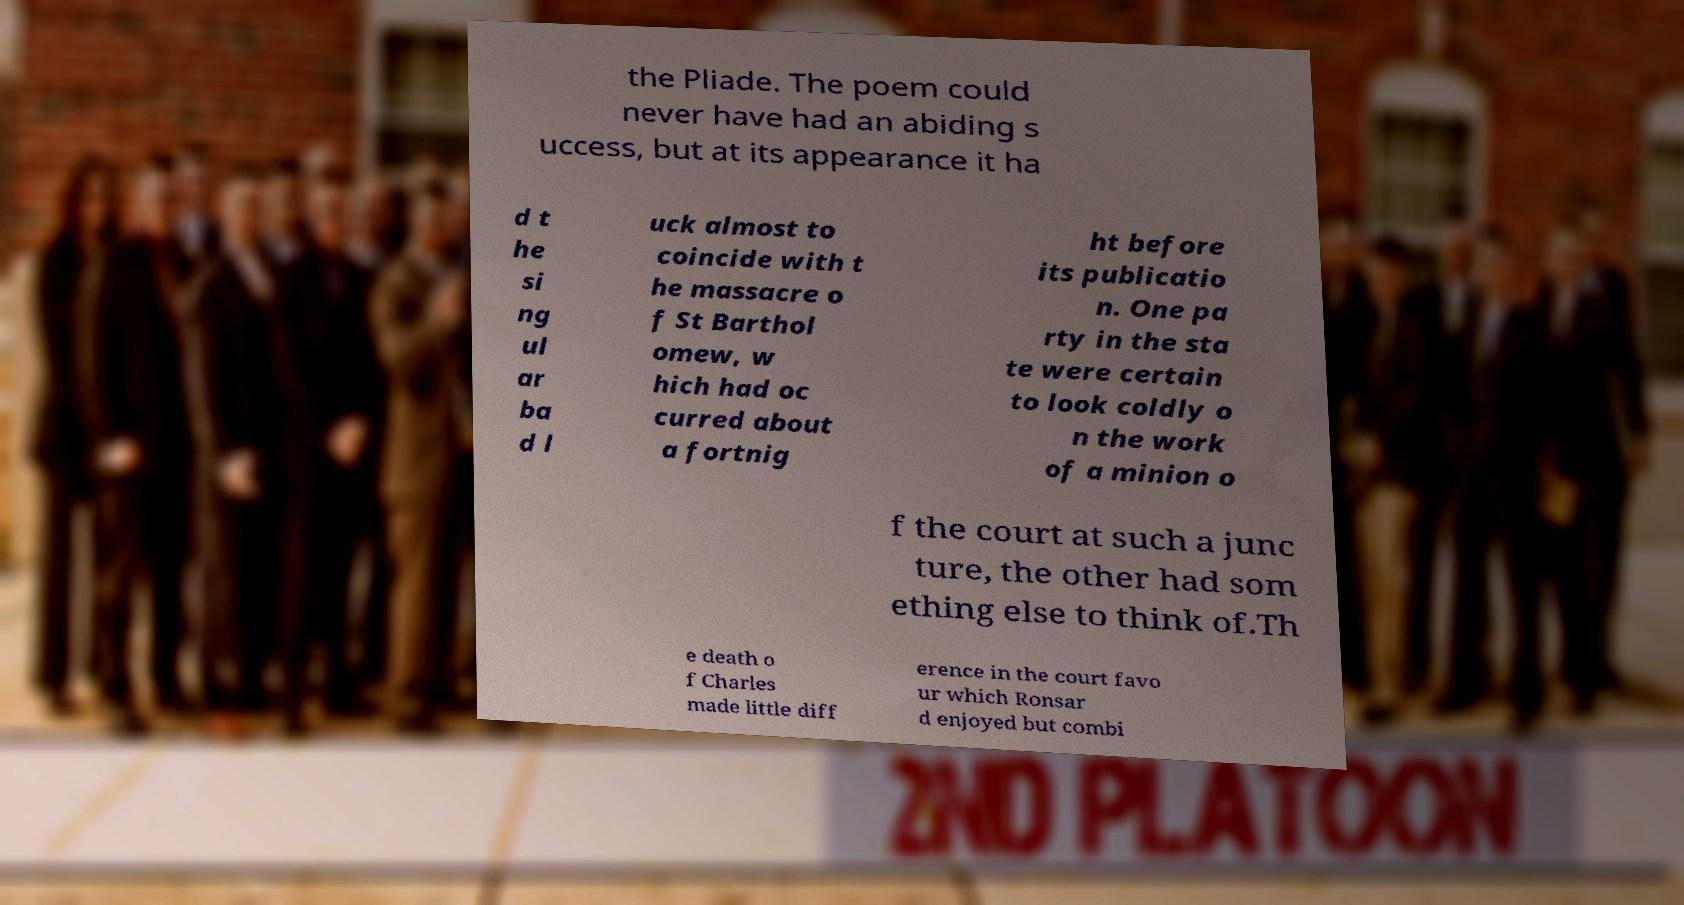I need the written content from this picture converted into text. Can you do that? the Pliade. The poem could never have had an abiding s uccess, but at its appearance it ha d t he si ng ul ar ba d l uck almost to coincide with t he massacre o f St Barthol omew, w hich had oc curred about a fortnig ht before its publicatio n. One pa rty in the sta te were certain to look coldly o n the work of a minion o f the court at such a junc ture, the other had som ething else to think of.Th e death o f Charles made little diff erence in the court favo ur which Ronsar d enjoyed but combi 